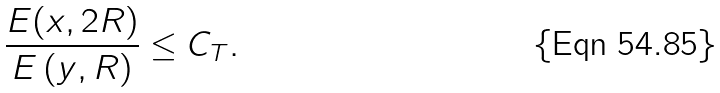<formula> <loc_0><loc_0><loc_500><loc_500>\frac { E ( x , 2 R ) } { E \left ( y , R \right ) } \leq C _ { T } .</formula> 